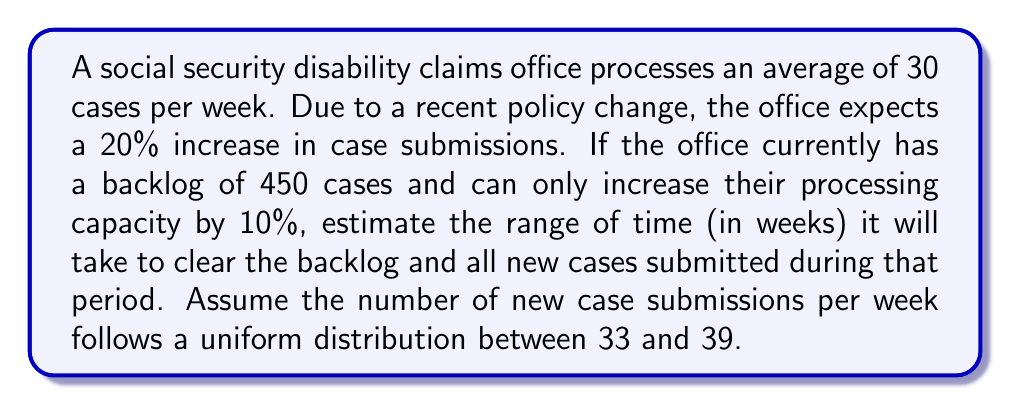Teach me how to tackle this problem. Let's approach this problem step-by-step:

1) Current processing rate: 30 cases/week
   New processing rate with 10% increase: $30 * 1.10 = 33$ cases/week

2) New case submission range: 33 to 39 cases/week
   Average new case submission: $\frac{33 + 39}{2} = 36$ cases/week

3) Net case accumulation per week:
   Minimum: $33 - 33 = 0$ cases/week
   Maximum: $39 - 33 = 6$ cases/week

4) Let $t$ be the number of weeks to clear the backlog. We can set up two inequalities:

   Minimum time: $450 + 0t \leq 33t$
   Maximum time: $450 + 6t \leq 33t$

5) Solving these inequalities:

   Minimum time: 
   $450 \leq 33t$
   $t \geq \frac{450}{33} \approx 13.64$ weeks

   Maximum time:
   $450 + 6t \leq 33t$
   $450 \leq 27t$
   $t \geq \frac{450}{27} \approx 16.67$ weeks

6) Rounding up to the nearest week (since we can't have partial weeks):
   Minimum time: 14 weeks
   Maximum time: 17 weeks

Therefore, the estimated range is 14 to 17 weeks.
Answer: The estimated time range to clear the backlog and process new cases is 14 to 17 weeks. 